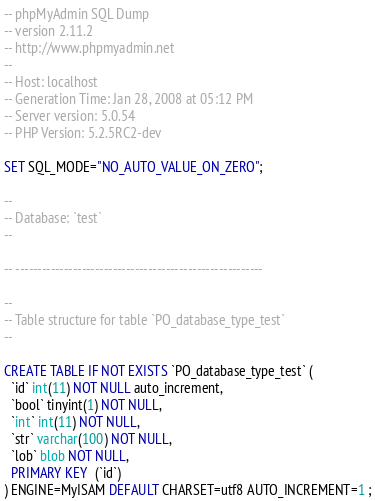Convert code to text. <code><loc_0><loc_0><loc_500><loc_500><_SQL_>-- phpMyAdmin SQL Dump
-- version 2.11.2
-- http://www.phpmyadmin.net
--
-- Host: localhost
-- Generation Time: Jan 28, 2008 at 05:12 PM
-- Server version: 5.0.54
-- PHP Version: 5.2.5RC2-dev

SET SQL_MODE="NO_AUTO_VALUE_ON_ZERO";

--
-- Database: `test`
--

-- --------------------------------------------------------

--
-- Table structure for table `PO_database_type_test`
--

CREATE TABLE IF NOT EXISTS `PO_database_type_test` (
  `id` int(11) NOT NULL auto_increment,
  `bool` tinyint(1) NOT NULL,
  `int` int(11) NOT NULL,
  `str` varchar(100) NOT NULL,
  `lob` blob NOT NULL,
  PRIMARY KEY  (`id`)
) ENGINE=MyISAM DEFAULT CHARSET=utf8 AUTO_INCREMENT=1 ;
</code> 